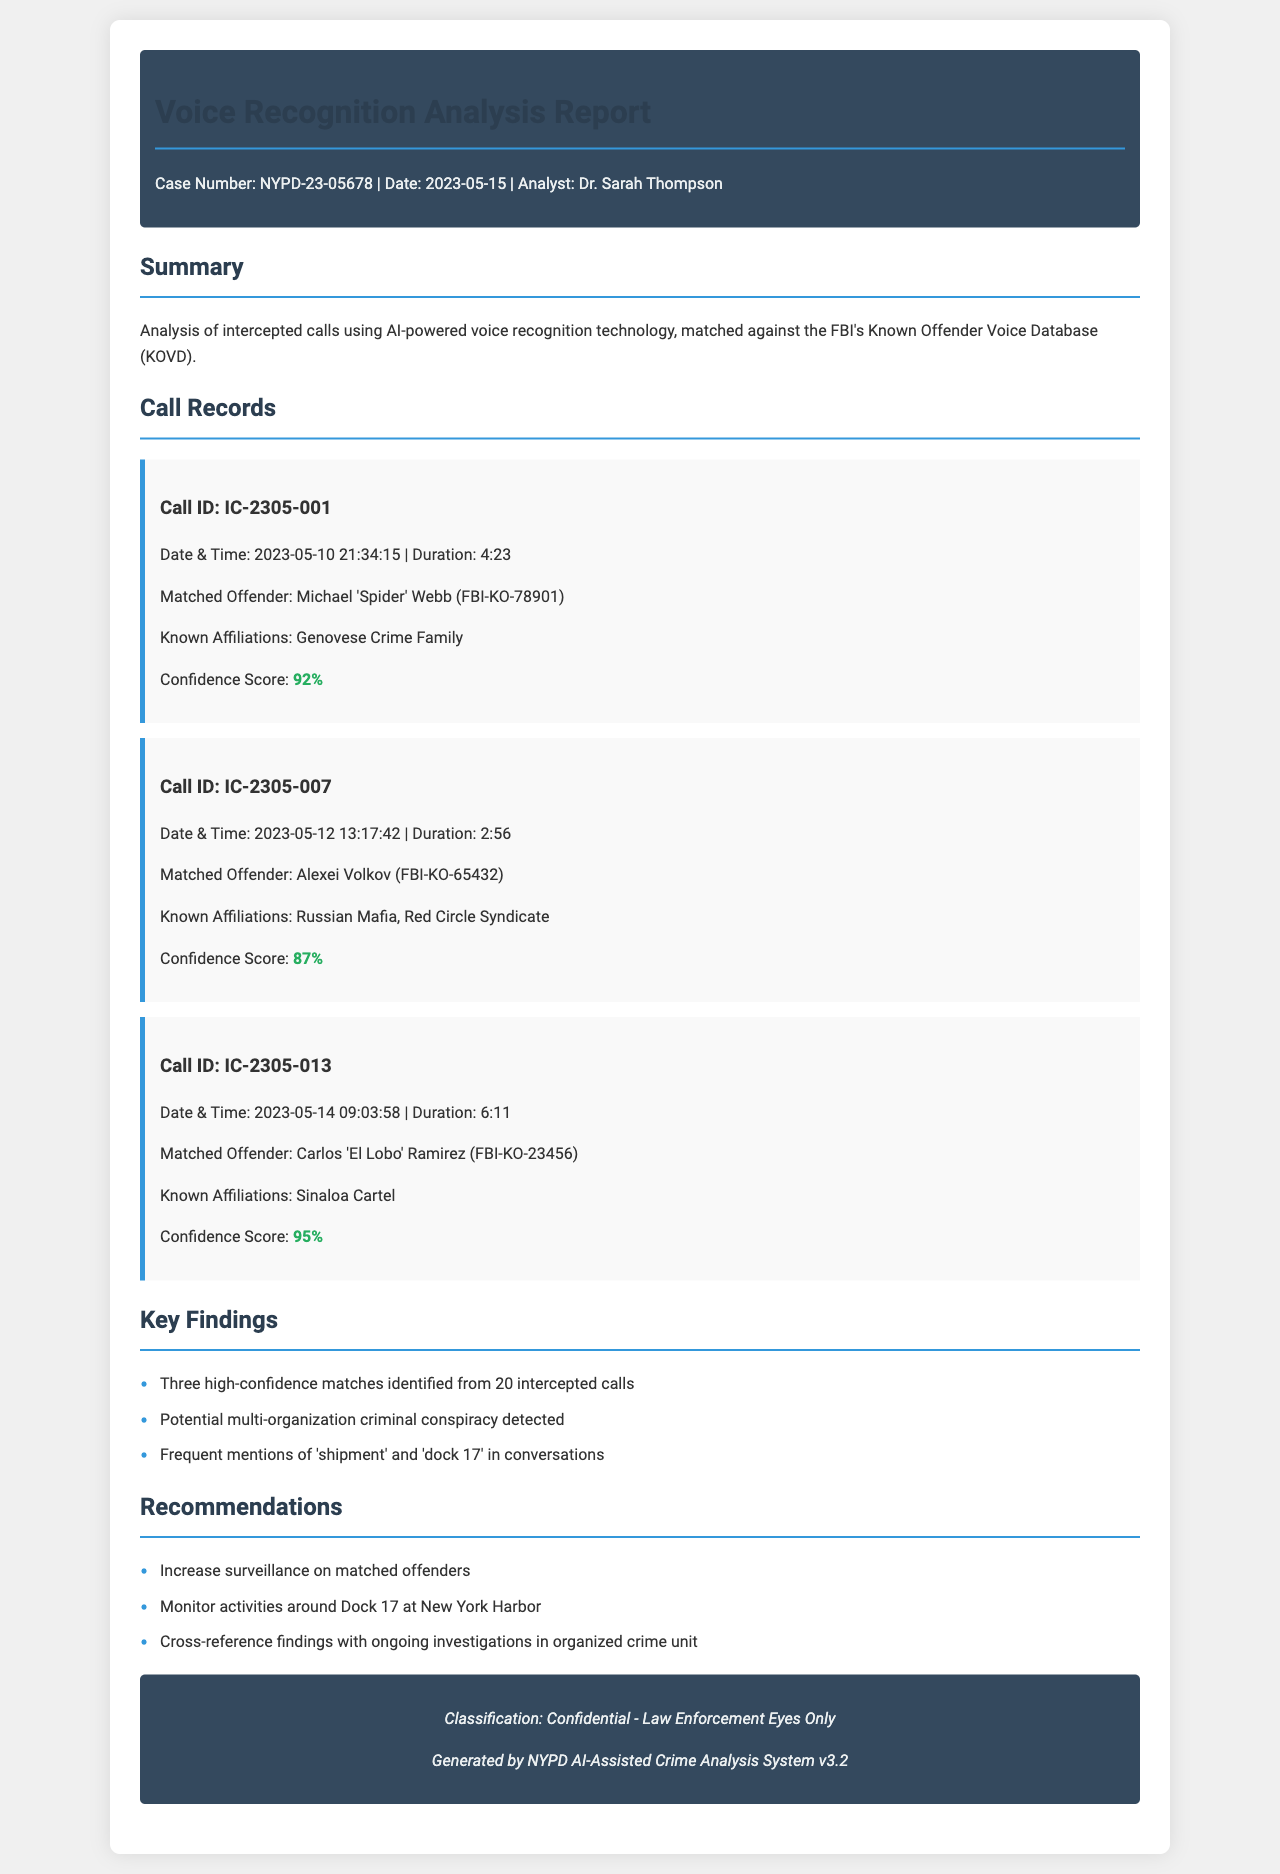What is the case number? The case number is presented in the header of the document.
Answer: NYPD-23-05678 Who is the analyst? The analyst's name is mentioned in the document header.
Answer: Dr. Sarah Thompson What was the duration of Call ID IC-2305-001? The duration of the call is specified directly beneath the call ID.
Answer: 4:23 What is the confidence score for Carlos 'El Lobo' Ramirez? The confidence score is indicated in the call record for this offender.
Answer: 95% How many high-confidence matches were identified? This information is summarized in the key findings section.
Answer: Three Which crime organization is associated with Michael 'Spider' Webb? Known affiliations for each matched offender are listed in their respective call records.
Answer: Genovese Crime Family What date was the analysis conducted? The date is provided in the header of the document.
Answer: 2023-05-15 What recommendation involves monitoring a specific location? The document contains recommendations that include specific actions.
Answer: Dock 17 at New York Harbor What was the date and time of Call ID IC-2305-007? The date and time are clearly mentioned in the individual call record.
Answer: 2023-05-12 13:17:42 